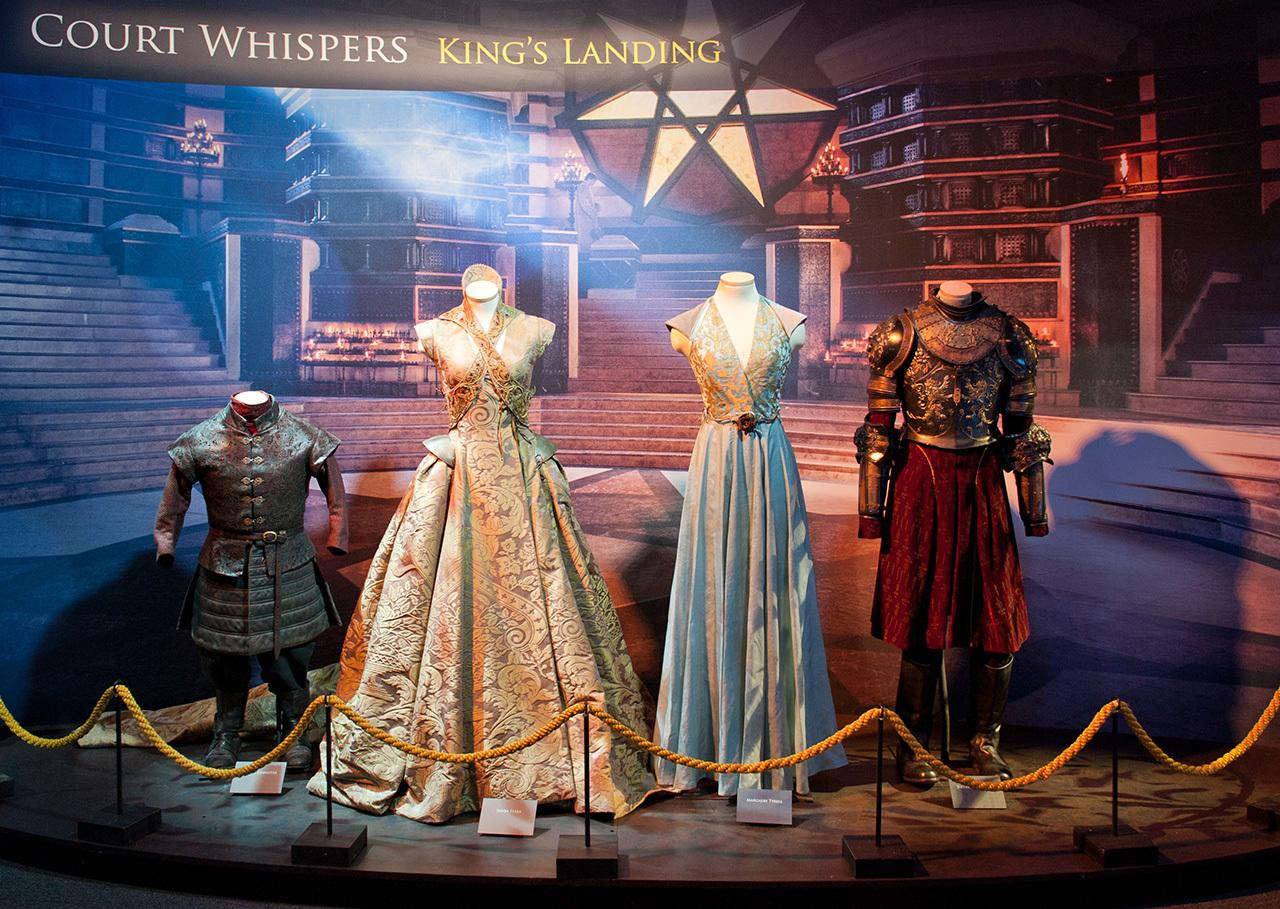Given an image, you will generate a caption for the image. The caption for this exhibit could be: 'A Journey through Royal Decadence: Exploring the Intricately Crafted Costumes of 'Court Whispers - King’s Landing''. This refined selection showcases exquisite craftsmanship, highlighting intricate patterns and luxurious fabrics that speak to the power and elegance of royal attire. The setting, 'Court Whispers - King's Landing,' suggests a narrative steeped in regal machinations and historical interpretations, making it clear that these costumes are more than mere attire; they are artifacts of a deeper storytelling craft, possibly inspired by the opulent and strategic world of medieval royals as depicted in popular fantasy genres. 